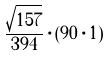Convert formula to latex. <formula><loc_0><loc_0><loc_500><loc_500>\frac { \sqrt { 1 5 7 } } { 3 9 4 } \cdot ( 9 0 \cdot 1 )</formula> 